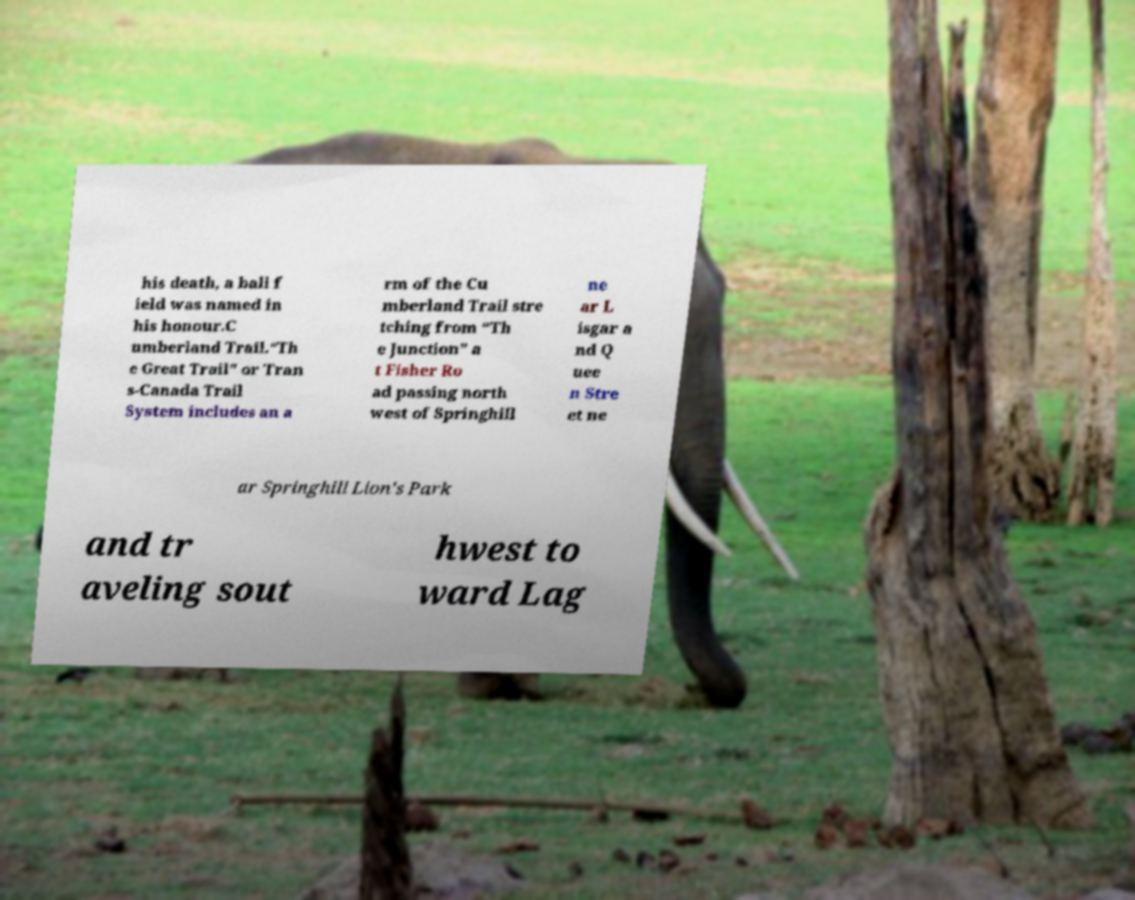There's text embedded in this image that I need extracted. Can you transcribe it verbatim? his death, a ball f ield was named in his honour.C umberland Trail.“Th e Great Trail” or Tran s-Canada Trail System includes an a rm of the Cu mberland Trail stre tching from “Th e Junction” a t Fisher Ro ad passing north west of Springhill ne ar L isgar a nd Q uee n Stre et ne ar Springhill Lion's Park and tr aveling sout hwest to ward Lag 